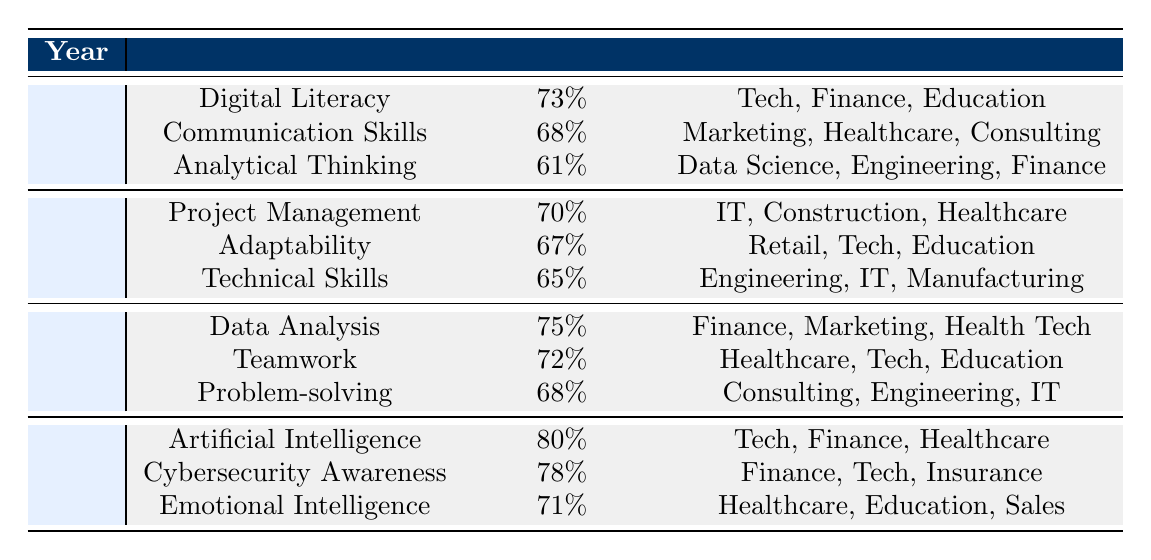What skill had the highest percentage required in 2023? In 2023, the skills listed are Artificial Intelligence (80%), Cybersecurity Awareness (78%), and Emotional Intelligence (71%). Among these, Artificial Intelligence has the highest percentage required at 80%.
Answer: Artificial Intelligence Which year saw a decrease in the percentage required for Analytical Thinking compared to the previous year? Analytical Thinking was listed in 2020 with 61%. The following year (2021) did not include this skill, so the decrease cannot be observed. Therefore, the year with the data showing no presence of Analytical Thinking subsequent to its listing shows that it did indeed decrease as it was not recorded in future years.
Answer: 2021 What is the average percentage required for skills in 2022? The skills in 2022 are Data Analysis (75%), Teamwork (72%), and Problem-solving (68%). The sum is 75 + 72 + 68 = 215, and there are 3 skills, so the average is 215/3 = 71.67.
Answer: 71.67 Is Cybersecurity Awareness more than 75% required in 2023? In 2023, Cybersecurity Awareness has a percentage required of 78%. Since 78% is more than 75%, the answer is yes.
Answer: Yes What percentage required for Project Management in 2021 is the difference from the percentage required for Digital Literacy in 2020? Project Management in 2021 has a requirement of 70%, while Digital Literacy in 2020 has 73%. The difference is 73 - 70 = 3%.
Answer: 3% 